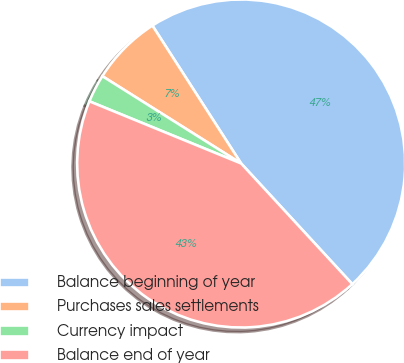<chart> <loc_0><loc_0><loc_500><loc_500><pie_chart><fcel>Balance beginning of year<fcel>Purchases sales settlements<fcel>Currency impact<fcel>Balance end of year<nl><fcel>47.25%<fcel>6.96%<fcel>2.75%<fcel>43.04%<nl></chart> 